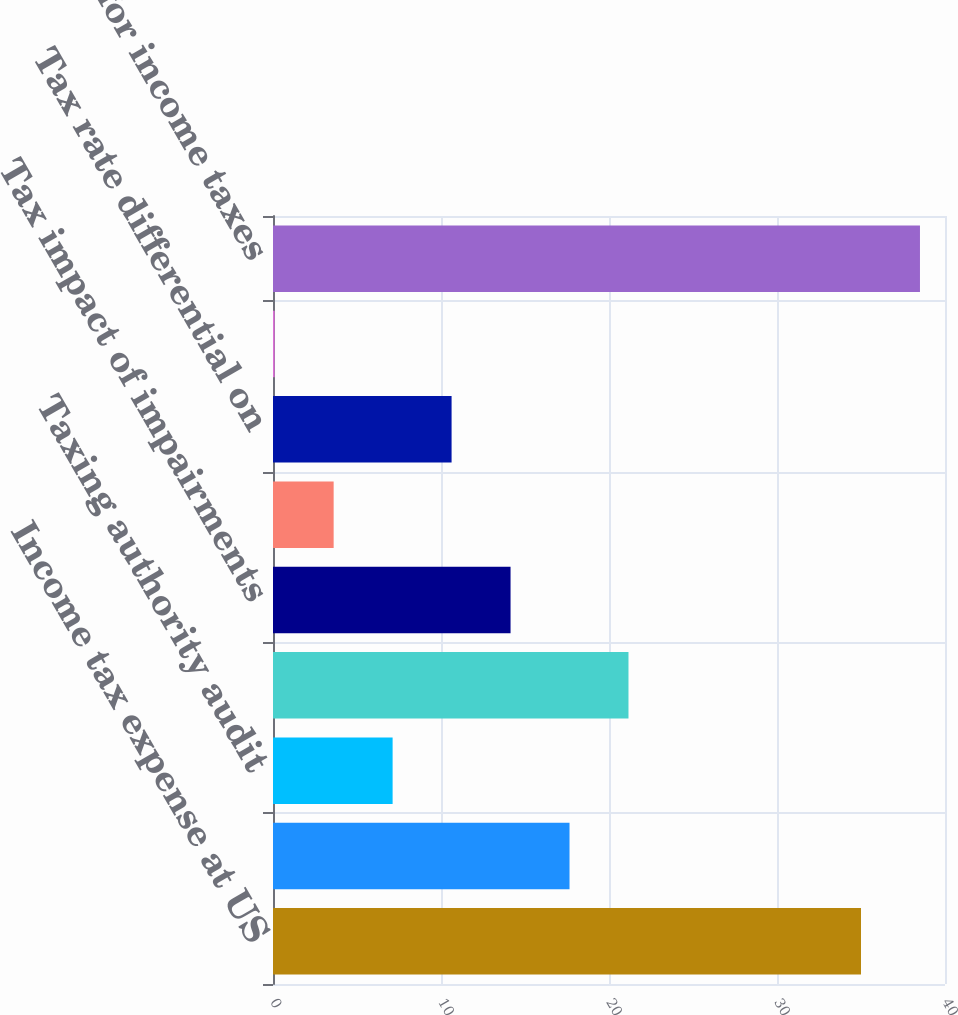<chart> <loc_0><loc_0><loc_500><loc_500><bar_chart><fcel>Income tax expense at US<fcel>Federal tax credits<fcel>Taxing authority audit<fcel>State and local income taxes<fcel>Tax impact of impairments<fcel>Tax impact of divestitures<fcel>Tax rate differential on<fcel>Other<fcel>Provision for income taxes<nl><fcel>35<fcel>17.65<fcel>7.12<fcel>21.16<fcel>14.14<fcel>3.61<fcel>10.63<fcel>0.1<fcel>38.51<nl></chart> 